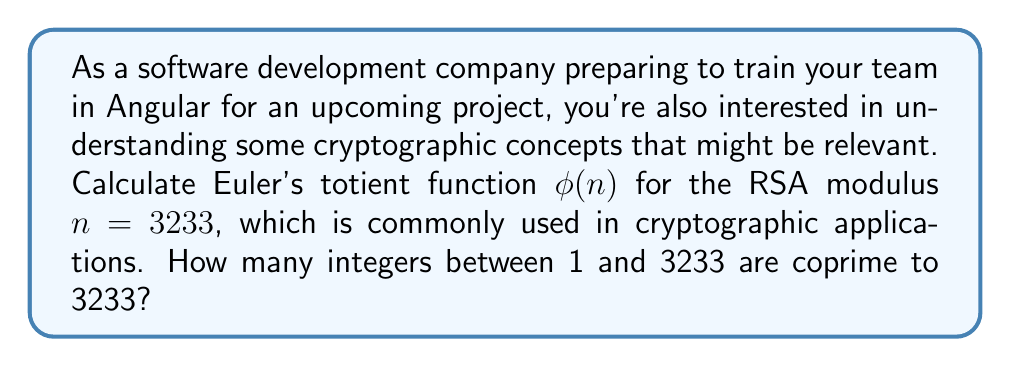Can you answer this question? To calculate Euler's totient function $\phi(n)$ for $n = 3233$, we'll follow these steps:

1) First, we need to factor 3233 into its prime factors:
   $3233 = 61 \times 53$

2) For a number $n$ that is a product of two distinct primes $p$ and $q$, Euler's totient function is given by:
   $\phi(n) = \phi(pq) = (p-1)(q-1)$

3) In this case:
   $p = 61$ and $q = 53$

4) Now we can calculate:
   $\phi(3233) = (61-1)(53-1)$
   $           = 60 \times 52$
   $           = 3120$

The result, 3120, represents the count of integers between 1 and 3233 that are coprime to 3233.

This calculation is crucial in RSA cryptography, where $\phi(n)$ is used to generate the public and private keys. Understanding this concept can help developers implement secure communication features in Angular applications.
Answer: $\phi(3233) = 3120$ 